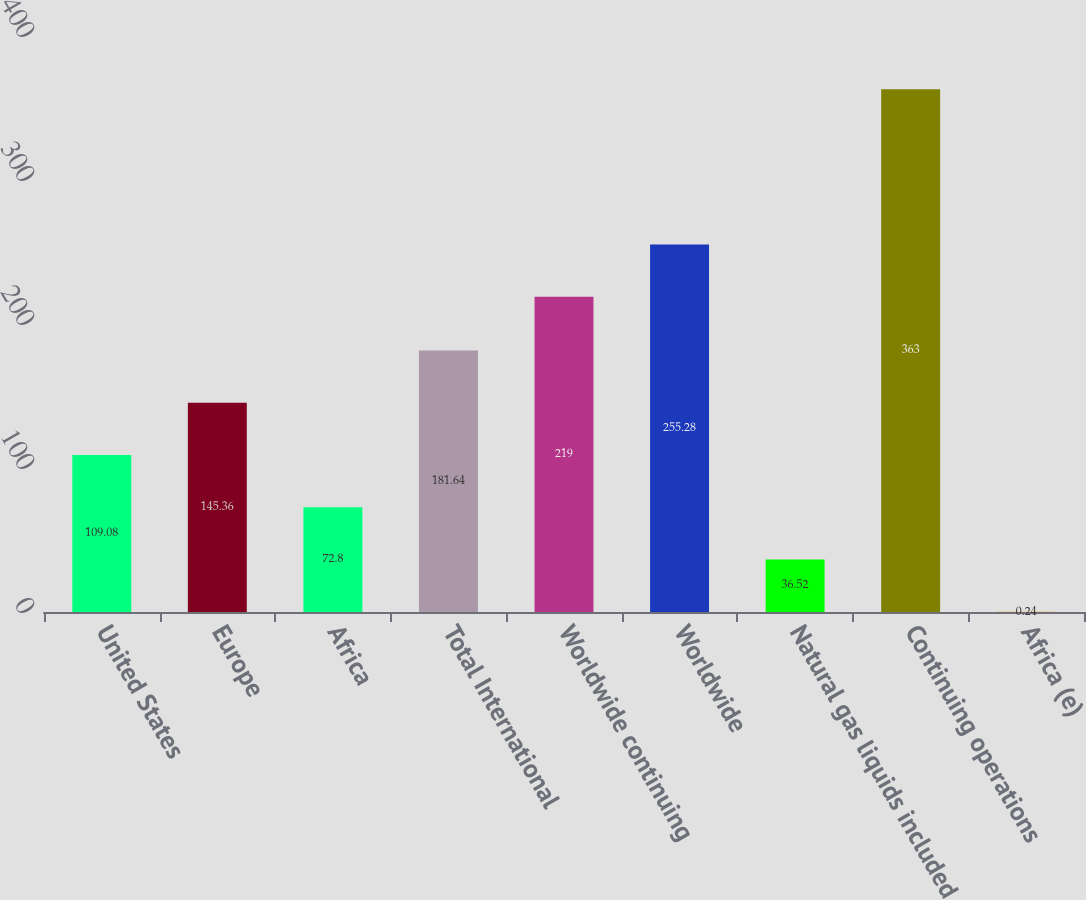Convert chart. <chart><loc_0><loc_0><loc_500><loc_500><bar_chart><fcel>United States<fcel>Europe<fcel>Africa<fcel>Total International<fcel>Worldwide continuing<fcel>Worldwide<fcel>Natural gas liquids included<fcel>Continuing operations<fcel>Africa (e)<nl><fcel>109.08<fcel>145.36<fcel>72.8<fcel>181.64<fcel>219<fcel>255.28<fcel>36.52<fcel>363<fcel>0.24<nl></chart> 